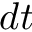<formula> <loc_0><loc_0><loc_500><loc_500>d t</formula> 